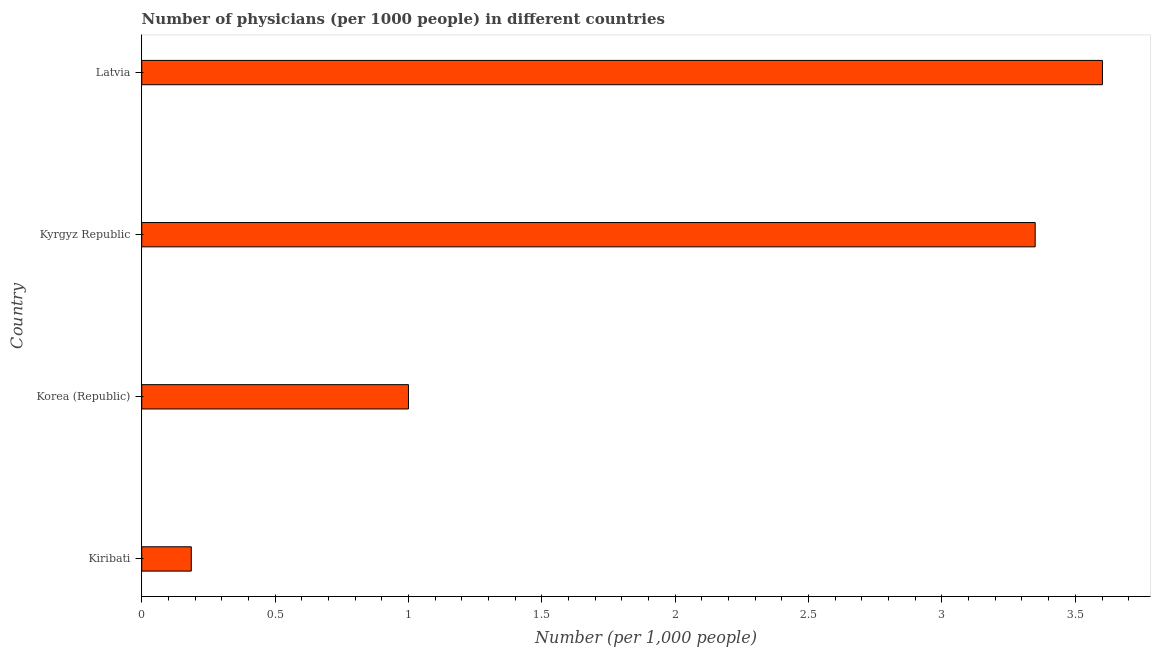Does the graph contain any zero values?
Your answer should be compact. No. Does the graph contain grids?
Your answer should be very brief. No. What is the title of the graph?
Offer a terse response. Number of physicians (per 1000 people) in different countries. What is the label or title of the X-axis?
Your answer should be compact. Number (per 1,0 people). Across all countries, what is the maximum number of physicians?
Your response must be concise. 3.6. Across all countries, what is the minimum number of physicians?
Provide a short and direct response. 0.19. In which country was the number of physicians maximum?
Provide a short and direct response. Latvia. In which country was the number of physicians minimum?
Give a very brief answer. Kiribati. What is the sum of the number of physicians?
Your response must be concise. 8.14. What is the difference between the number of physicians in Kyrgyz Republic and Latvia?
Your answer should be compact. -0.25. What is the average number of physicians per country?
Your answer should be compact. 2.03. What is the median number of physicians?
Offer a very short reply. 2.17. What is the difference between the highest and the second highest number of physicians?
Give a very brief answer. 0.25. What is the difference between the highest and the lowest number of physicians?
Provide a succinct answer. 3.42. How many bars are there?
Provide a succinct answer. 4. Are all the bars in the graph horizontal?
Your answer should be compact. Yes. How many countries are there in the graph?
Offer a terse response. 4. Are the values on the major ticks of X-axis written in scientific E-notation?
Give a very brief answer. No. What is the Number (per 1,000 people) of Kiribati?
Your response must be concise. 0.19. What is the Number (per 1,000 people) of Korea (Republic)?
Offer a very short reply. 1. What is the Number (per 1,000 people) of Kyrgyz Republic?
Keep it short and to the point. 3.35. What is the Number (per 1,000 people) in Latvia?
Ensure brevity in your answer.  3.6. What is the difference between the Number (per 1,000 people) in Kiribati and Korea (Republic)?
Provide a succinct answer. -0.81. What is the difference between the Number (per 1,000 people) in Kiribati and Kyrgyz Republic?
Provide a succinct answer. -3.16. What is the difference between the Number (per 1,000 people) in Kiribati and Latvia?
Provide a short and direct response. -3.42. What is the difference between the Number (per 1,000 people) in Korea (Republic) and Kyrgyz Republic?
Make the answer very short. -2.35. What is the difference between the Number (per 1,000 people) in Korea (Republic) and Latvia?
Make the answer very short. -2.6. What is the difference between the Number (per 1,000 people) in Kyrgyz Republic and Latvia?
Your response must be concise. -0.25. What is the ratio of the Number (per 1,000 people) in Kiribati to that in Korea (Republic)?
Offer a very short reply. 0.19. What is the ratio of the Number (per 1,000 people) in Kiribati to that in Kyrgyz Republic?
Offer a terse response. 0.06. What is the ratio of the Number (per 1,000 people) in Kiribati to that in Latvia?
Offer a terse response. 0.05. What is the ratio of the Number (per 1,000 people) in Korea (Republic) to that in Kyrgyz Republic?
Offer a terse response. 0.3. What is the ratio of the Number (per 1,000 people) in Korea (Republic) to that in Latvia?
Offer a terse response. 0.28. What is the ratio of the Number (per 1,000 people) in Kyrgyz Republic to that in Latvia?
Offer a terse response. 0.93. 